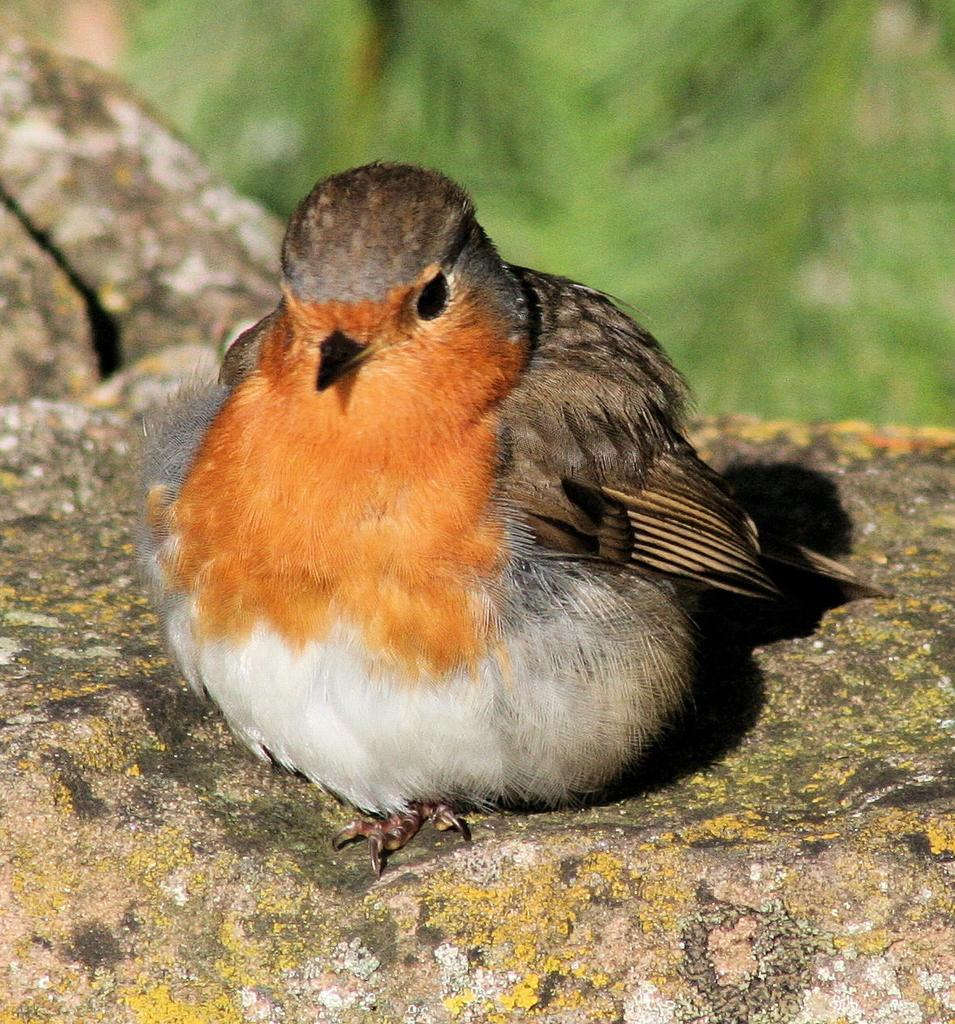What type of animal can be seen in the image? There is a bird in the image. Where is the bird located? The bird is sitting on a rock. Can you describe the bird's coloring? The bird has brown, white, and black coloring. What can be seen in the background of the image? There are trees in the background of the image, but they are blurry. What type of club is the bird holding in the image? There is no club present in the image; the bird is sitting on a rock. Is there a lamp visible in the image? No, there is no lamp present in the image. 